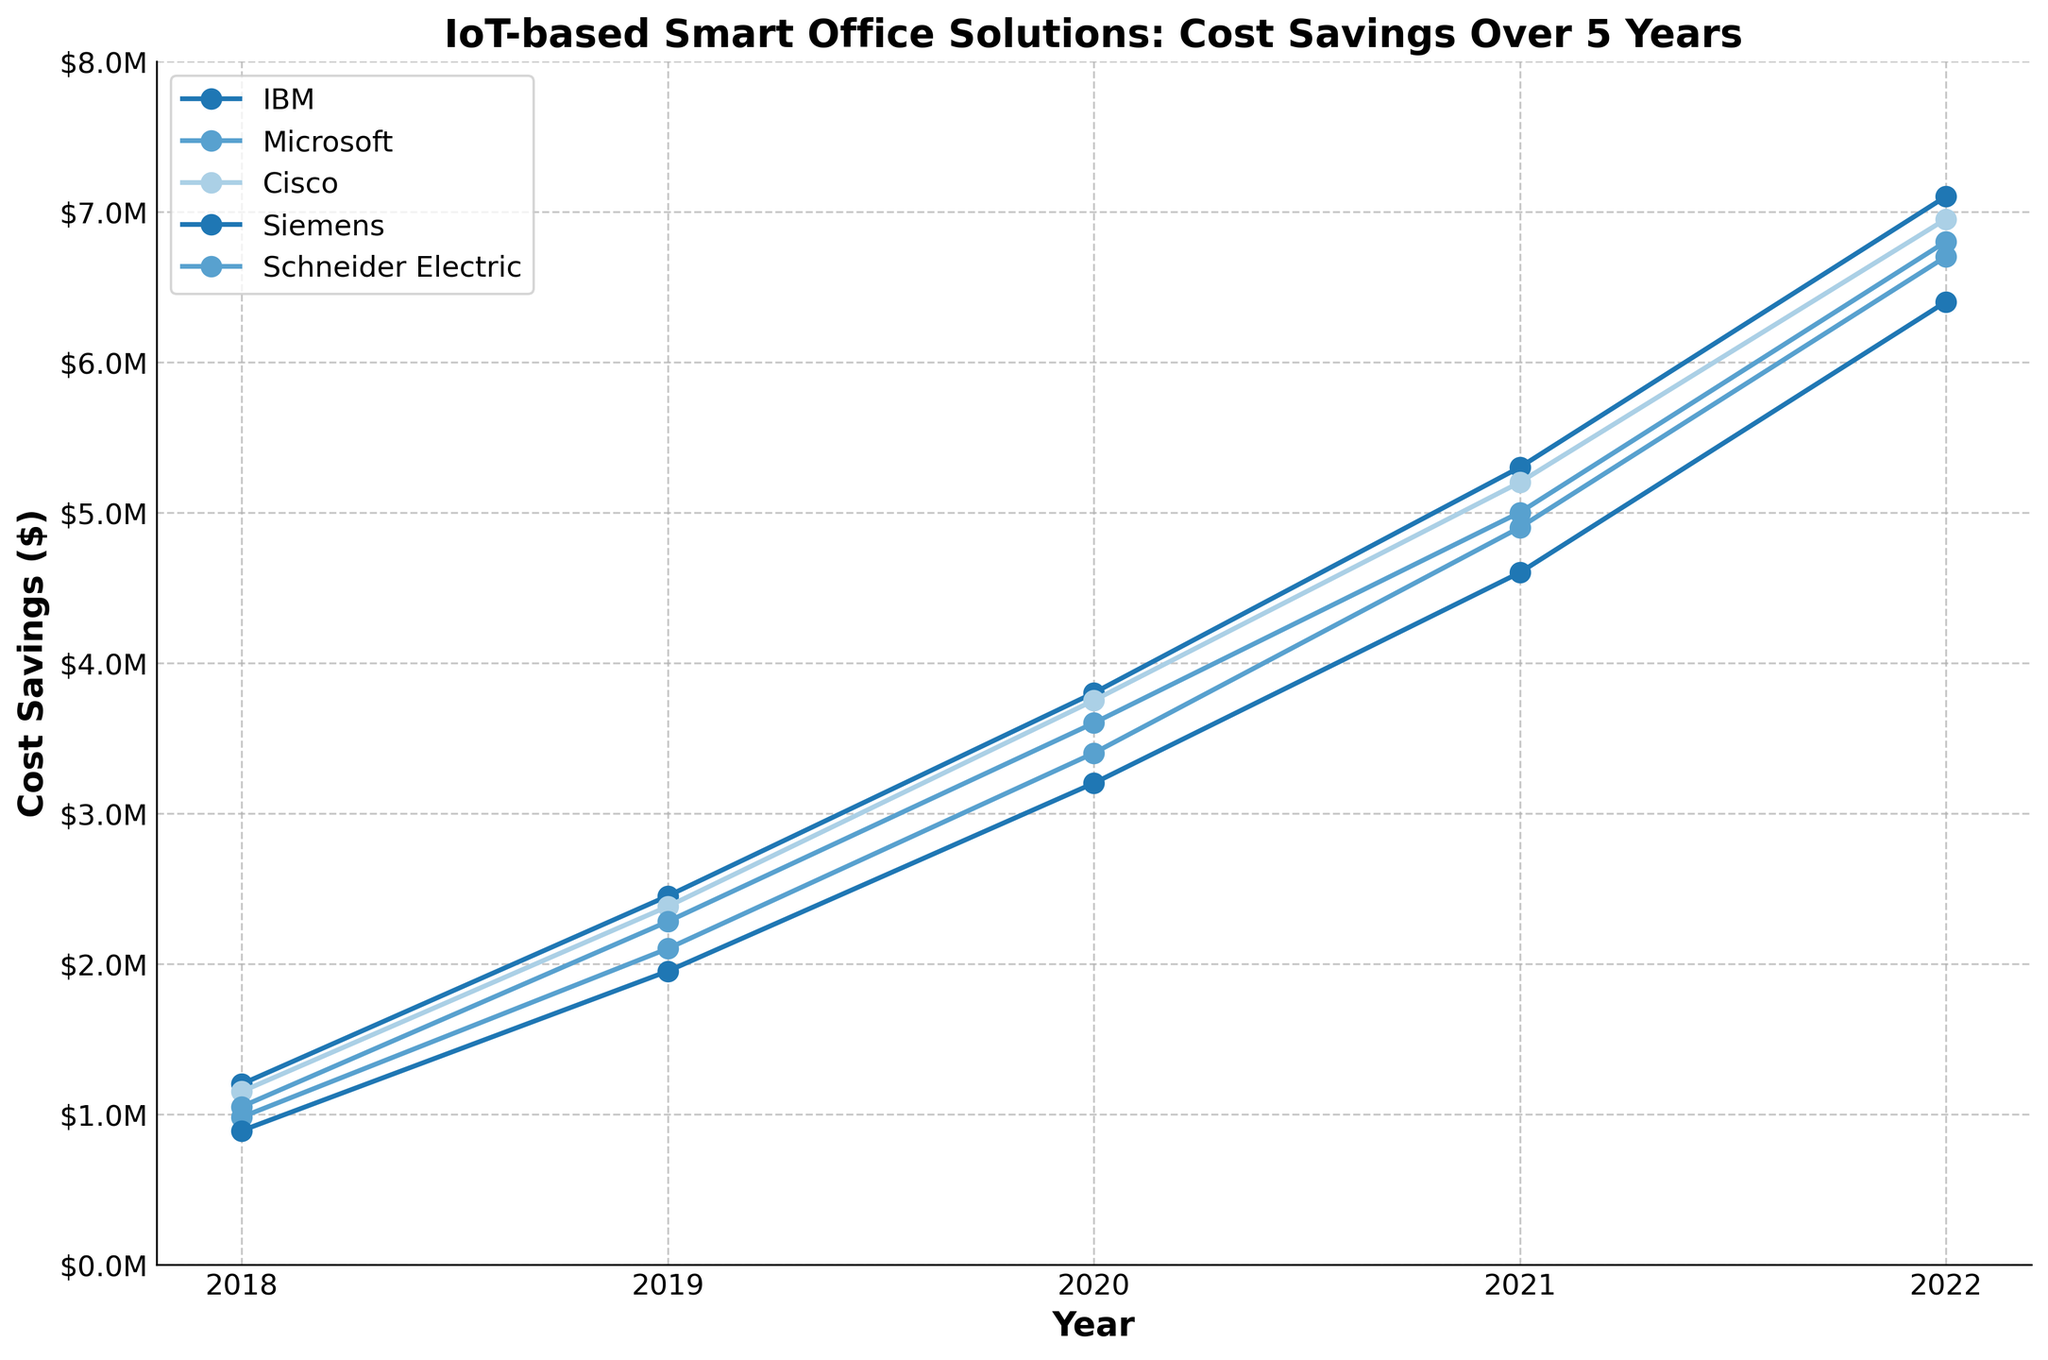What's the overall trend of cost savings over the 5 years for all companies? By observing the plot, all companies show an increasing trend in cost savings from 2018 to 2022. The savings consistently grow each year for every company.
Answer: Increasing Which company achieved the highest cost savings in 2022? By looking at the endpoints of the lines on the far right of the graph for the year 2022, IBM achieved the highest cost savings at $7,100,000.
Answer: IBM Did Microsoft ever achieve greater cost savings than Cisco in the 5-year period? By comparing the lines of Microsoft and Cisco at each year, Microsoft had greater cost savings in 2018 and 2019, while Cisco surpassed Microsoft from 2020 to 2022.
Answer: Yes Among IBM, Cisco, and Siemens, which company had the smallest increment in cost savings from 2021 to 2022? By calculating the difference between the values for 2021 and 2022 for IBM ($1,800,000), Cisco ($1,750,000), and Siemens ($1,800,000), Cisco had the smallest increment.
Answer: Cisco What was the cost savings increase for Schneider Electric from 2018 to 2022? Subtract the savings in 2018 ($1,050,000) from the savings in 2022 ($6,800,000): $6,800,000 - $1,050,000 = $5,750,000.
Answer: $5,750,000 Compare the total cost savings for IBM and Siemens over the 5 years. Which one is higher? Sum the values for IBM and Siemens from 2018 to 2022: IBM (1,200,000 + 2,450,000 + 3,800,000 + 5,300,000 + 7,100,000 = 19,850,000) and Siemens (890,000 + 1,950,000 + 3,200,000 + 4,600,000 + 6,400,000 = 17,040,000). IBM has higher total savings.
Answer: IBM Which company saw the most significant increase in cost savings from 2019 to 2020? By looking at the slopes of the lines between 2019 and 2020, the steepest slope indicates the most significant increase, which is for IBM ($1,350,000 increment).
Answer: IBM How much more savings did Cisco achieve in 2021 compared to 2019? Subtract the savings in 2019 ($2,380,000) from the savings in 2021 ($5,200,000): $5,200,000 - $2,380,000 = $2,820,000.
Answer: $2,820,000 What is the average cost savings for Microsoft over the 5 years? Sum the values for each year and divide by the number of years: (980,000 + 2,100,000 + 3,400,000 + 4,900,000 + 6,700,000) / 5 = 3,616,000.
Answer: $3,616,000 What visual pattern is consistent across all companies from 2018 to 2022? All lines on the chart show a steady upward trajectory, indicating a consistent increase in cost savings over each year for all companies.
Answer: Upward trajectory 